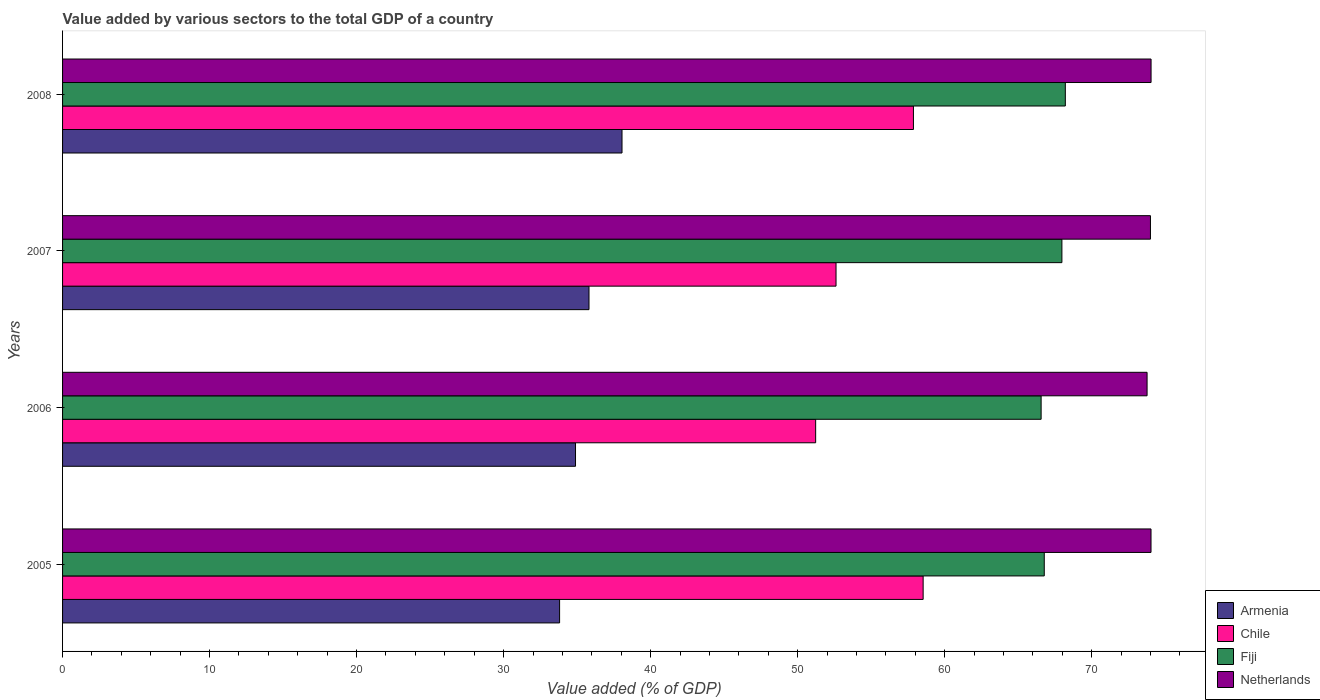How many different coloured bars are there?
Make the answer very short. 4. Are the number of bars per tick equal to the number of legend labels?
Offer a terse response. Yes. Are the number of bars on each tick of the Y-axis equal?
Keep it short and to the point. Yes. How many bars are there on the 3rd tick from the top?
Your answer should be compact. 4. What is the label of the 1st group of bars from the top?
Make the answer very short. 2008. What is the value added by various sectors to the total GDP in Fiji in 2008?
Make the answer very short. 68.21. Across all years, what is the maximum value added by various sectors to the total GDP in Netherlands?
Provide a succinct answer. 74.04. Across all years, what is the minimum value added by various sectors to the total GDP in Fiji?
Make the answer very short. 66.56. In which year was the value added by various sectors to the total GDP in Armenia maximum?
Provide a short and direct response. 2008. In which year was the value added by various sectors to the total GDP in Armenia minimum?
Offer a very short reply. 2005. What is the total value added by various sectors to the total GDP in Netherlands in the graph?
Ensure brevity in your answer.  295.85. What is the difference between the value added by various sectors to the total GDP in Armenia in 2005 and that in 2006?
Keep it short and to the point. -1.08. What is the difference between the value added by various sectors to the total GDP in Chile in 2005 and the value added by various sectors to the total GDP in Armenia in 2007?
Make the answer very short. 22.73. What is the average value added by various sectors to the total GDP in Armenia per year?
Provide a succinct answer. 35.64. In the year 2007, what is the difference between the value added by various sectors to the total GDP in Armenia and value added by various sectors to the total GDP in Netherlands?
Ensure brevity in your answer.  -38.19. What is the ratio of the value added by various sectors to the total GDP in Netherlands in 2005 to that in 2006?
Keep it short and to the point. 1. What is the difference between the highest and the second highest value added by various sectors to the total GDP in Netherlands?
Offer a terse response. 0. What is the difference between the highest and the lowest value added by various sectors to the total GDP in Armenia?
Give a very brief answer. 4.25. Is the sum of the value added by various sectors to the total GDP in Armenia in 2005 and 2008 greater than the maximum value added by various sectors to the total GDP in Netherlands across all years?
Ensure brevity in your answer.  No. Is it the case that in every year, the sum of the value added by various sectors to the total GDP in Netherlands and value added by various sectors to the total GDP in Fiji is greater than the sum of value added by various sectors to the total GDP in Chile and value added by various sectors to the total GDP in Armenia?
Offer a very short reply. No. What does the 2nd bar from the top in 2007 represents?
Your answer should be very brief. Fiji. What does the 3rd bar from the bottom in 2006 represents?
Your response must be concise. Fiji. Is it the case that in every year, the sum of the value added by various sectors to the total GDP in Chile and value added by various sectors to the total GDP in Fiji is greater than the value added by various sectors to the total GDP in Netherlands?
Your response must be concise. Yes. How many bars are there?
Offer a very short reply. 16. How many years are there in the graph?
Your response must be concise. 4. Does the graph contain any zero values?
Ensure brevity in your answer.  No. Does the graph contain grids?
Your answer should be compact. No. Where does the legend appear in the graph?
Make the answer very short. Bottom right. What is the title of the graph?
Provide a succinct answer. Value added by various sectors to the total GDP of a country. Does "Zimbabwe" appear as one of the legend labels in the graph?
Provide a short and direct response. No. What is the label or title of the X-axis?
Make the answer very short. Value added (% of GDP). What is the label or title of the Y-axis?
Your answer should be very brief. Years. What is the Value added (% of GDP) in Armenia in 2005?
Ensure brevity in your answer.  33.81. What is the Value added (% of GDP) of Chile in 2005?
Your answer should be compact. 58.54. What is the Value added (% of GDP) of Fiji in 2005?
Offer a terse response. 66.78. What is the Value added (% of GDP) in Netherlands in 2005?
Make the answer very short. 74.04. What is the Value added (% of GDP) of Armenia in 2006?
Ensure brevity in your answer.  34.89. What is the Value added (% of GDP) in Chile in 2006?
Provide a succinct answer. 51.23. What is the Value added (% of GDP) of Fiji in 2006?
Your answer should be very brief. 66.56. What is the Value added (% of GDP) of Netherlands in 2006?
Keep it short and to the point. 73.77. What is the Value added (% of GDP) in Armenia in 2007?
Your response must be concise. 35.81. What is the Value added (% of GDP) in Chile in 2007?
Your answer should be very brief. 52.61. What is the Value added (% of GDP) of Fiji in 2007?
Give a very brief answer. 67.98. What is the Value added (% of GDP) in Netherlands in 2007?
Offer a very short reply. 74. What is the Value added (% of GDP) of Armenia in 2008?
Offer a terse response. 38.05. What is the Value added (% of GDP) in Chile in 2008?
Your response must be concise. 57.88. What is the Value added (% of GDP) in Fiji in 2008?
Your response must be concise. 68.21. What is the Value added (% of GDP) of Netherlands in 2008?
Provide a succinct answer. 74.04. Across all years, what is the maximum Value added (% of GDP) in Armenia?
Ensure brevity in your answer.  38.05. Across all years, what is the maximum Value added (% of GDP) of Chile?
Your answer should be very brief. 58.54. Across all years, what is the maximum Value added (% of GDP) in Fiji?
Provide a succinct answer. 68.21. Across all years, what is the maximum Value added (% of GDP) of Netherlands?
Your response must be concise. 74.04. Across all years, what is the minimum Value added (% of GDP) of Armenia?
Your answer should be very brief. 33.81. Across all years, what is the minimum Value added (% of GDP) of Chile?
Your answer should be very brief. 51.23. Across all years, what is the minimum Value added (% of GDP) in Fiji?
Ensure brevity in your answer.  66.56. Across all years, what is the minimum Value added (% of GDP) of Netherlands?
Your response must be concise. 73.77. What is the total Value added (% of GDP) in Armenia in the graph?
Offer a very short reply. 142.56. What is the total Value added (% of GDP) of Chile in the graph?
Your answer should be very brief. 220.26. What is the total Value added (% of GDP) of Fiji in the graph?
Provide a succinct answer. 269.53. What is the total Value added (% of GDP) of Netherlands in the graph?
Your answer should be very brief. 295.85. What is the difference between the Value added (% of GDP) of Armenia in 2005 and that in 2006?
Give a very brief answer. -1.08. What is the difference between the Value added (% of GDP) in Chile in 2005 and that in 2006?
Your answer should be very brief. 7.31. What is the difference between the Value added (% of GDP) in Fiji in 2005 and that in 2006?
Your response must be concise. 0.21. What is the difference between the Value added (% of GDP) of Netherlands in 2005 and that in 2006?
Provide a short and direct response. 0.27. What is the difference between the Value added (% of GDP) of Armenia in 2005 and that in 2007?
Make the answer very short. -2. What is the difference between the Value added (% of GDP) in Chile in 2005 and that in 2007?
Make the answer very short. 5.93. What is the difference between the Value added (% of GDP) in Fiji in 2005 and that in 2007?
Your answer should be compact. -1.2. What is the difference between the Value added (% of GDP) in Netherlands in 2005 and that in 2007?
Keep it short and to the point. 0.04. What is the difference between the Value added (% of GDP) of Armenia in 2005 and that in 2008?
Offer a terse response. -4.25. What is the difference between the Value added (% of GDP) in Chile in 2005 and that in 2008?
Provide a succinct answer. 0.66. What is the difference between the Value added (% of GDP) in Fiji in 2005 and that in 2008?
Make the answer very short. -1.43. What is the difference between the Value added (% of GDP) in Netherlands in 2005 and that in 2008?
Make the answer very short. -0. What is the difference between the Value added (% of GDP) in Armenia in 2006 and that in 2007?
Ensure brevity in your answer.  -0.92. What is the difference between the Value added (% of GDP) of Chile in 2006 and that in 2007?
Your response must be concise. -1.39. What is the difference between the Value added (% of GDP) in Fiji in 2006 and that in 2007?
Your answer should be very brief. -1.41. What is the difference between the Value added (% of GDP) in Netherlands in 2006 and that in 2007?
Your response must be concise. -0.23. What is the difference between the Value added (% of GDP) in Armenia in 2006 and that in 2008?
Provide a succinct answer. -3.16. What is the difference between the Value added (% of GDP) in Chile in 2006 and that in 2008?
Your answer should be very brief. -6.65. What is the difference between the Value added (% of GDP) in Fiji in 2006 and that in 2008?
Offer a terse response. -1.65. What is the difference between the Value added (% of GDP) of Netherlands in 2006 and that in 2008?
Keep it short and to the point. -0.27. What is the difference between the Value added (% of GDP) of Armenia in 2007 and that in 2008?
Give a very brief answer. -2.25. What is the difference between the Value added (% of GDP) in Chile in 2007 and that in 2008?
Ensure brevity in your answer.  -5.26. What is the difference between the Value added (% of GDP) in Fiji in 2007 and that in 2008?
Offer a terse response. -0.23. What is the difference between the Value added (% of GDP) in Netherlands in 2007 and that in 2008?
Make the answer very short. -0.04. What is the difference between the Value added (% of GDP) of Armenia in 2005 and the Value added (% of GDP) of Chile in 2006?
Provide a succinct answer. -17.42. What is the difference between the Value added (% of GDP) of Armenia in 2005 and the Value added (% of GDP) of Fiji in 2006?
Offer a terse response. -32.75. What is the difference between the Value added (% of GDP) of Armenia in 2005 and the Value added (% of GDP) of Netherlands in 2006?
Offer a very short reply. -39.96. What is the difference between the Value added (% of GDP) in Chile in 2005 and the Value added (% of GDP) in Fiji in 2006?
Keep it short and to the point. -8.03. What is the difference between the Value added (% of GDP) of Chile in 2005 and the Value added (% of GDP) of Netherlands in 2006?
Your response must be concise. -15.23. What is the difference between the Value added (% of GDP) of Fiji in 2005 and the Value added (% of GDP) of Netherlands in 2006?
Your response must be concise. -6.99. What is the difference between the Value added (% of GDP) in Armenia in 2005 and the Value added (% of GDP) in Chile in 2007?
Your answer should be very brief. -18.8. What is the difference between the Value added (% of GDP) in Armenia in 2005 and the Value added (% of GDP) in Fiji in 2007?
Provide a succinct answer. -34.17. What is the difference between the Value added (% of GDP) of Armenia in 2005 and the Value added (% of GDP) of Netherlands in 2007?
Provide a succinct answer. -40.19. What is the difference between the Value added (% of GDP) of Chile in 2005 and the Value added (% of GDP) of Fiji in 2007?
Provide a succinct answer. -9.44. What is the difference between the Value added (% of GDP) of Chile in 2005 and the Value added (% of GDP) of Netherlands in 2007?
Offer a terse response. -15.46. What is the difference between the Value added (% of GDP) in Fiji in 2005 and the Value added (% of GDP) in Netherlands in 2007?
Ensure brevity in your answer.  -7.22. What is the difference between the Value added (% of GDP) in Armenia in 2005 and the Value added (% of GDP) in Chile in 2008?
Your answer should be compact. -24.07. What is the difference between the Value added (% of GDP) in Armenia in 2005 and the Value added (% of GDP) in Fiji in 2008?
Provide a succinct answer. -34.4. What is the difference between the Value added (% of GDP) in Armenia in 2005 and the Value added (% of GDP) in Netherlands in 2008?
Provide a short and direct response. -40.23. What is the difference between the Value added (% of GDP) in Chile in 2005 and the Value added (% of GDP) in Fiji in 2008?
Provide a short and direct response. -9.67. What is the difference between the Value added (% of GDP) of Chile in 2005 and the Value added (% of GDP) of Netherlands in 2008?
Your answer should be compact. -15.5. What is the difference between the Value added (% of GDP) of Fiji in 2005 and the Value added (% of GDP) of Netherlands in 2008?
Your answer should be compact. -7.27. What is the difference between the Value added (% of GDP) in Armenia in 2006 and the Value added (% of GDP) in Chile in 2007?
Give a very brief answer. -17.72. What is the difference between the Value added (% of GDP) of Armenia in 2006 and the Value added (% of GDP) of Fiji in 2007?
Keep it short and to the point. -33.09. What is the difference between the Value added (% of GDP) of Armenia in 2006 and the Value added (% of GDP) of Netherlands in 2007?
Your answer should be compact. -39.11. What is the difference between the Value added (% of GDP) of Chile in 2006 and the Value added (% of GDP) of Fiji in 2007?
Ensure brevity in your answer.  -16.75. What is the difference between the Value added (% of GDP) in Chile in 2006 and the Value added (% of GDP) in Netherlands in 2007?
Provide a succinct answer. -22.77. What is the difference between the Value added (% of GDP) in Fiji in 2006 and the Value added (% of GDP) in Netherlands in 2007?
Offer a terse response. -7.44. What is the difference between the Value added (% of GDP) in Armenia in 2006 and the Value added (% of GDP) in Chile in 2008?
Make the answer very short. -22.99. What is the difference between the Value added (% of GDP) of Armenia in 2006 and the Value added (% of GDP) of Fiji in 2008?
Offer a very short reply. -33.32. What is the difference between the Value added (% of GDP) in Armenia in 2006 and the Value added (% of GDP) in Netherlands in 2008?
Give a very brief answer. -39.15. What is the difference between the Value added (% of GDP) in Chile in 2006 and the Value added (% of GDP) in Fiji in 2008?
Provide a short and direct response. -16.98. What is the difference between the Value added (% of GDP) in Chile in 2006 and the Value added (% of GDP) in Netherlands in 2008?
Offer a very short reply. -22.82. What is the difference between the Value added (% of GDP) of Fiji in 2006 and the Value added (% of GDP) of Netherlands in 2008?
Make the answer very short. -7.48. What is the difference between the Value added (% of GDP) in Armenia in 2007 and the Value added (% of GDP) in Chile in 2008?
Make the answer very short. -22.07. What is the difference between the Value added (% of GDP) in Armenia in 2007 and the Value added (% of GDP) in Fiji in 2008?
Offer a terse response. -32.4. What is the difference between the Value added (% of GDP) of Armenia in 2007 and the Value added (% of GDP) of Netherlands in 2008?
Your response must be concise. -38.23. What is the difference between the Value added (% of GDP) in Chile in 2007 and the Value added (% of GDP) in Fiji in 2008?
Your answer should be very brief. -15.6. What is the difference between the Value added (% of GDP) of Chile in 2007 and the Value added (% of GDP) of Netherlands in 2008?
Ensure brevity in your answer.  -21.43. What is the difference between the Value added (% of GDP) of Fiji in 2007 and the Value added (% of GDP) of Netherlands in 2008?
Give a very brief answer. -6.06. What is the average Value added (% of GDP) in Armenia per year?
Your answer should be very brief. 35.64. What is the average Value added (% of GDP) of Chile per year?
Offer a very short reply. 55.06. What is the average Value added (% of GDP) in Fiji per year?
Offer a very short reply. 67.38. What is the average Value added (% of GDP) in Netherlands per year?
Offer a terse response. 73.96. In the year 2005, what is the difference between the Value added (% of GDP) of Armenia and Value added (% of GDP) of Chile?
Provide a succinct answer. -24.73. In the year 2005, what is the difference between the Value added (% of GDP) in Armenia and Value added (% of GDP) in Fiji?
Your answer should be compact. -32.97. In the year 2005, what is the difference between the Value added (% of GDP) of Armenia and Value added (% of GDP) of Netherlands?
Offer a very short reply. -40.23. In the year 2005, what is the difference between the Value added (% of GDP) of Chile and Value added (% of GDP) of Fiji?
Offer a terse response. -8.24. In the year 2005, what is the difference between the Value added (% of GDP) in Chile and Value added (% of GDP) in Netherlands?
Offer a very short reply. -15.5. In the year 2005, what is the difference between the Value added (% of GDP) in Fiji and Value added (% of GDP) in Netherlands?
Give a very brief answer. -7.26. In the year 2006, what is the difference between the Value added (% of GDP) in Armenia and Value added (% of GDP) in Chile?
Keep it short and to the point. -16.34. In the year 2006, what is the difference between the Value added (% of GDP) of Armenia and Value added (% of GDP) of Fiji?
Give a very brief answer. -31.67. In the year 2006, what is the difference between the Value added (% of GDP) of Armenia and Value added (% of GDP) of Netherlands?
Offer a very short reply. -38.88. In the year 2006, what is the difference between the Value added (% of GDP) in Chile and Value added (% of GDP) in Fiji?
Make the answer very short. -15.34. In the year 2006, what is the difference between the Value added (% of GDP) of Chile and Value added (% of GDP) of Netherlands?
Offer a very short reply. -22.54. In the year 2006, what is the difference between the Value added (% of GDP) of Fiji and Value added (% of GDP) of Netherlands?
Your response must be concise. -7.21. In the year 2007, what is the difference between the Value added (% of GDP) in Armenia and Value added (% of GDP) in Chile?
Keep it short and to the point. -16.8. In the year 2007, what is the difference between the Value added (% of GDP) in Armenia and Value added (% of GDP) in Fiji?
Offer a terse response. -32.17. In the year 2007, what is the difference between the Value added (% of GDP) in Armenia and Value added (% of GDP) in Netherlands?
Your answer should be compact. -38.19. In the year 2007, what is the difference between the Value added (% of GDP) in Chile and Value added (% of GDP) in Fiji?
Make the answer very short. -15.36. In the year 2007, what is the difference between the Value added (% of GDP) of Chile and Value added (% of GDP) of Netherlands?
Provide a succinct answer. -21.39. In the year 2007, what is the difference between the Value added (% of GDP) in Fiji and Value added (% of GDP) in Netherlands?
Offer a very short reply. -6.02. In the year 2008, what is the difference between the Value added (% of GDP) in Armenia and Value added (% of GDP) in Chile?
Offer a very short reply. -19.82. In the year 2008, what is the difference between the Value added (% of GDP) in Armenia and Value added (% of GDP) in Fiji?
Make the answer very short. -30.16. In the year 2008, what is the difference between the Value added (% of GDP) in Armenia and Value added (% of GDP) in Netherlands?
Your answer should be compact. -35.99. In the year 2008, what is the difference between the Value added (% of GDP) of Chile and Value added (% of GDP) of Fiji?
Make the answer very short. -10.33. In the year 2008, what is the difference between the Value added (% of GDP) in Chile and Value added (% of GDP) in Netherlands?
Offer a terse response. -16.16. In the year 2008, what is the difference between the Value added (% of GDP) in Fiji and Value added (% of GDP) in Netherlands?
Make the answer very short. -5.83. What is the ratio of the Value added (% of GDP) in Armenia in 2005 to that in 2006?
Provide a short and direct response. 0.97. What is the ratio of the Value added (% of GDP) of Chile in 2005 to that in 2006?
Make the answer very short. 1.14. What is the ratio of the Value added (% of GDP) in Armenia in 2005 to that in 2007?
Provide a short and direct response. 0.94. What is the ratio of the Value added (% of GDP) of Chile in 2005 to that in 2007?
Ensure brevity in your answer.  1.11. What is the ratio of the Value added (% of GDP) in Fiji in 2005 to that in 2007?
Offer a very short reply. 0.98. What is the ratio of the Value added (% of GDP) of Netherlands in 2005 to that in 2007?
Provide a succinct answer. 1. What is the ratio of the Value added (% of GDP) of Armenia in 2005 to that in 2008?
Keep it short and to the point. 0.89. What is the ratio of the Value added (% of GDP) in Chile in 2005 to that in 2008?
Offer a terse response. 1.01. What is the ratio of the Value added (% of GDP) in Netherlands in 2005 to that in 2008?
Offer a very short reply. 1. What is the ratio of the Value added (% of GDP) of Armenia in 2006 to that in 2007?
Your response must be concise. 0.97. What is the ratio of the Value added (% of GDP) of Chile in 2006 to that in 2007?
Your response must be concise. 0.97. What is the ratio of the Value added (% of GDP) of Fiji in 2006 to that in 2007?
Your answer should be very brief. 0.98. What is the ratio of the Value added (% of GDP) of Armenia in 2006 to that in 2008?
Ensure brevity in your answer.  0.92. What is the ratio of the Value added (% of GDP) of Chile in 2006 to that in 2008?
Ensure brevity in your answer.  0.89. What is the ratio of the Value added (% of GDP) of Fiji in 2006 to that in 2008?
Make the answer very short. 0.98. What is the ratio of the Value added (% of GDP) in Netherlands in 2006 to that in 2008?
Offer a very short reply. 1. What is the ratio of the Value added (% of GDP) of Armenia in 2007 to that in 2008?
Provide a short and direct response. 0.94. What is the ratio of the Value added (% of GDP) of Chile in 2007 to that in 2008?
Offer a very short reply. 0.91. What is the ratio of the Value added (% of GDP) of Fiji in 2007 to that in 2008?
Offer a very short reply. 1. What is the ratio of the Value added (% of GDP) in Netherlands in 2007 to that in 2008?
Provide a succinct answer. 1. What is the difference between the highest and the second highest Value added (% of GDP) of Armenia?
Offer a terse response. 2.25. What is the difference between the highest and the second highest Value added (% of GDP) in Chile?
Provide a succinct answer. 0.66. What is the difference between the highest and the second highest Value added (% of GDP) in Fiji?
Provide a succinct answer. 0.23. What is the difference between the highest and the second highest Value added (% of GDP) of Netherlands?
Make the answer very short. 0. What is the difference between the highest and the lowest Value added (% of GDP) in Armenia?
Your response must be concise. 4.25. What is the difference between the highest and the lowest Value added (% of GDP) of Chile?
Your answer should be compact. 7.31. What is the difference between the highest and the lowest Value added (% of GDP) in Fiji?
Offer a very short reply. 1.65. What is the difference between the highest and the lowest Value added (% of GDP) in Netherlands?
Provide a short and direct response. 0.27. 